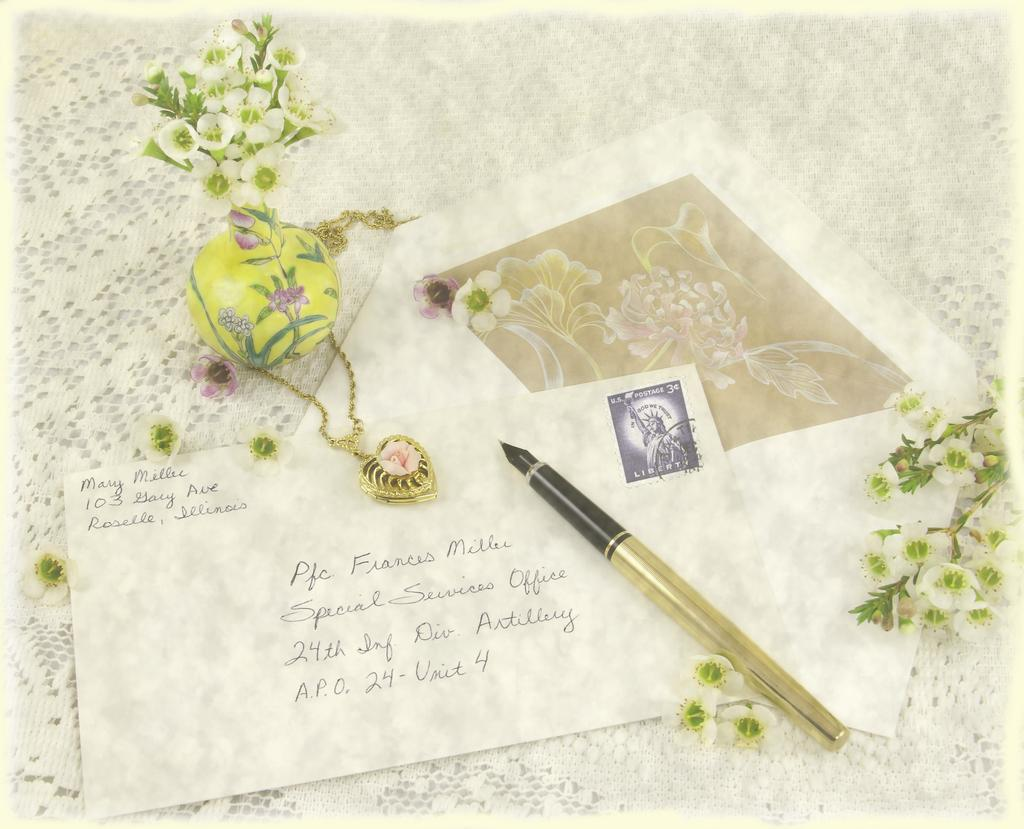<image>
Write a terse but informative summary of the picture. A nice letter envelope sending to Frances Miller 